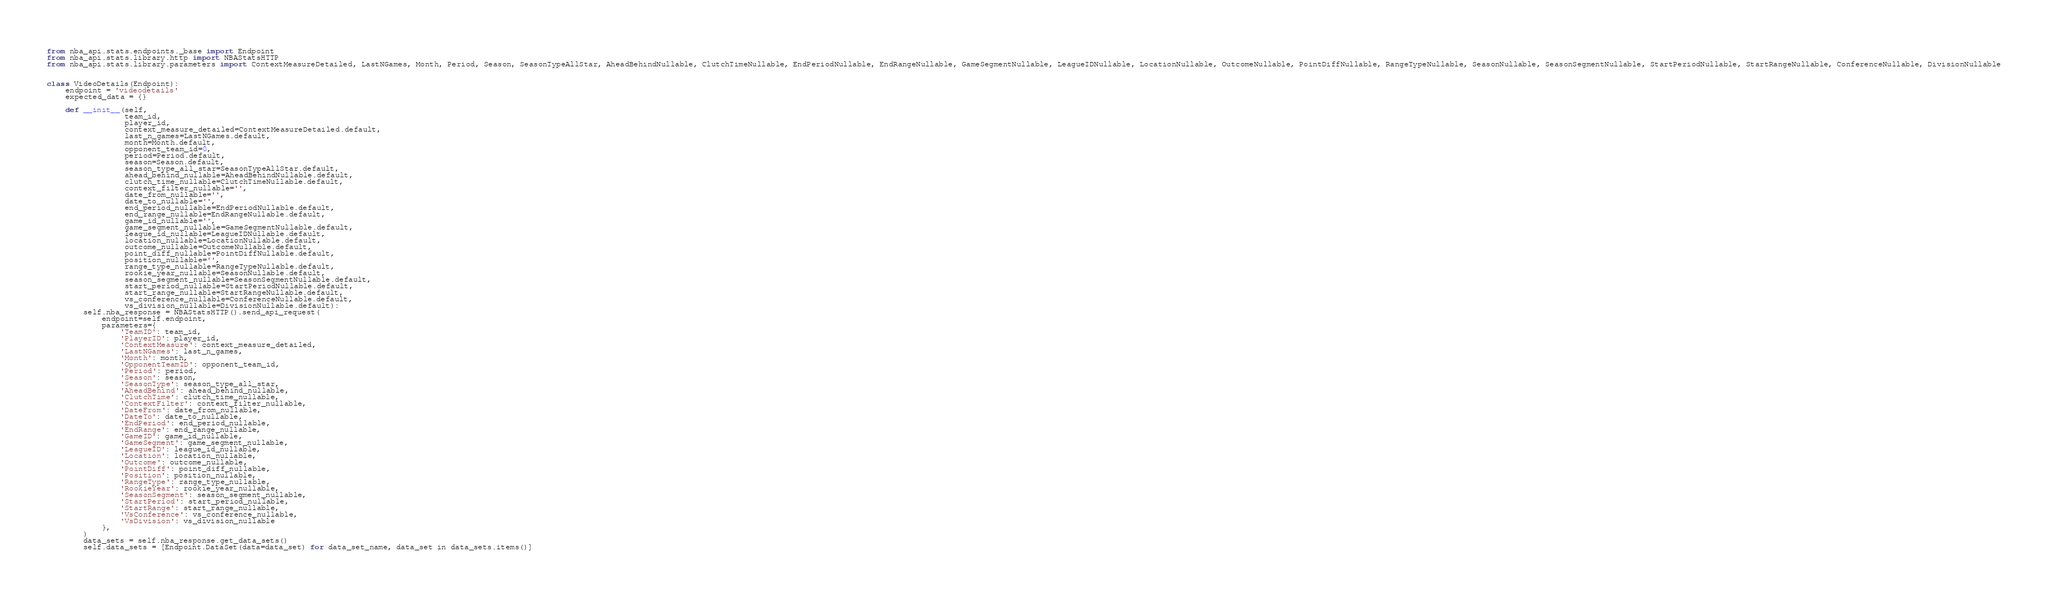Convert code to text. <code><loc_0><loc_0><loc_500><loc_500><_Python_>from nba_api.stats.endpoints._base import Endpoint
from nba_api.stats.library.http import NBAStatsHTTP
from nba_api.stats.library.parameters import ContextMeasureDetailed, LastNGames, Month, Period, Season, SeasonTypeAllStar, AheadBehindNullable, ClutchTimeNullable, EndPeriodNullable, EndRangeNullable, GameSegmentNullable, LeagueIDNullable, LocationNullable, OutcomeNullable, PointDiffNullable, RangeTypeNullable, SeasonNullable, SeasonSegmentNullable, StartPeriodNullable, StartRangeNullable, ConferenceNullable, DivisionNullable


class VideoDetails(Endpoint):
    endpoint = 'videodetails'
    expected_data = {}

    def __init__(self,
                 team_id,
                 player_id,
                 context_measure_detailed=ContextMeasureDetailed.default,
                 last_n_games=LastNGames.default,
                 month=Month.default,
                 opponent_team_id=0,
                 period=Period.default,
                 season=Season.default,
                 season_type_all_star=SeasonTypeAllStar.default,
                 ahead_behind_nullable=AheadBehindNullable.default,
                 clutch_time_nullable=ClutchTimeNullable.default,
                 context_filter_nullable='',
                 date_from_nullable='',
                 date_to_nullable='',
                 end_period_nullable=EndPeriodNullable.default,
                 end_range_nullable=EndRangeNullable.default,
                 game_id_nullable='',
                 game_segment_nullable=GameSegmentNullable.default,
                 league_id_nullable=LeagueIDNullable.default,
                 location_nullable=LocationNullable.default,
                 outcome_nullable=OutcomeNullable.default,
                 point_diff_nullable=PointDiffNullable.default,
                 position_nullable='',
                 range_type_nullable=RangeTypeNullable.default,
                 rookie_year_nullable=SeasonNullable.default,
                 season_segment_nullable=SeasonSegmentNullable.default,
                 start_period_nullable=StartPeriodNullable.default,
                 start_range_nullable=StartRangeNullable.default,
                 vs_conference_nullable=ConferenceNullable.default,
                 vs_division_nullable=DivisionNullable.default):
        self.nba_response = NBAStatsHTTP().send_api_request(
            endpoint=self.endpoint,
            parameters={
                'TeamID': team_id,
                'PlayerID': player_id,
                'ContextMeasure': context_measure_detailed,
                'LastNGames': last_n_games,
                'Month': month,
                'OpponentTeamID': opponent_team_id,
                'Period': period,
                'Season': season,
                'SeasonType': season_type_all_star,
                'AheadBehind': ahead_behind_nullable,
                'ClutchTime': clutch_time_nullable,
                'ContextFilter': context_filter_nullable,
                'DateFrom': date_from_nullable,
                'DateTo': date_to_nullable,
                'EndPeriod': end_period_nullable,
                'EndRange': end_range_nullable,
                'GameID': game_id_nullable,
                'GameSegment': game_segment_nullable,
                'LeagueID': league_id_nullable,
                'Location': location_nullable,
                'Outcome': outcome_nullable,
                'PointDiff': point_diff_nullable,
                'Position': position_nullable,
                'RangeType': range_type_nullable,
                'RookieYear': rookie_year_nullable,
                'SeasonSegment': season_segment_nullable,
                'StartPeriod': start_period_nullable,
                'StartRange': start_range_nullable,
                'VsConference': vs_conference_nullable,
                'VsDivision': vs_division_nullable
            },
        )
        data_sets = self.nba_response.get_data_sets()
        self.data_sets = [Endpoint.DataSet(data=data_set) for data_set_name, data_set in data_sets.items()]

</code> 